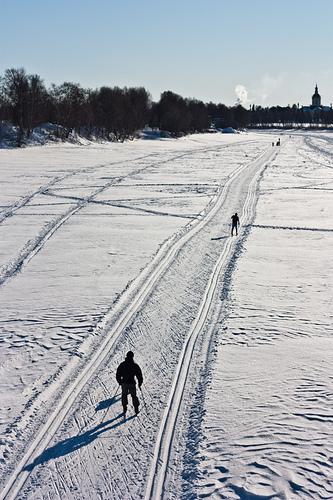Is it cold?
Quick response, please. Yes. How long is the track?
Give a very brief answer. 2 miles. Are they downhill or cross country skiing?
Concise answer only. Cross country. 